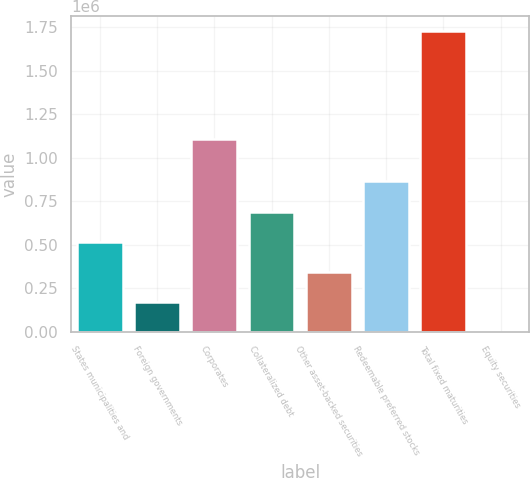Convert chart to OTSL. <chart><loc_0><loc_0><loc_500><loc_500><bar_chart><fcel>States municipalities and<fcel>Foreign governments<fcel>Corporates<fcel>Collateralized debt<fcel>Other asset-backed securities<fcel>Redeemable preferred stocks<fcel>Total fixed maturities<fcel>Equity securities<nl><fcel>518047<fcel>172684<fcel>1.10546e+06<fcel>690728<fcel>345365<fcel>863409<fcel>1.72682e+06<fcel>2.46<nl></chart> 